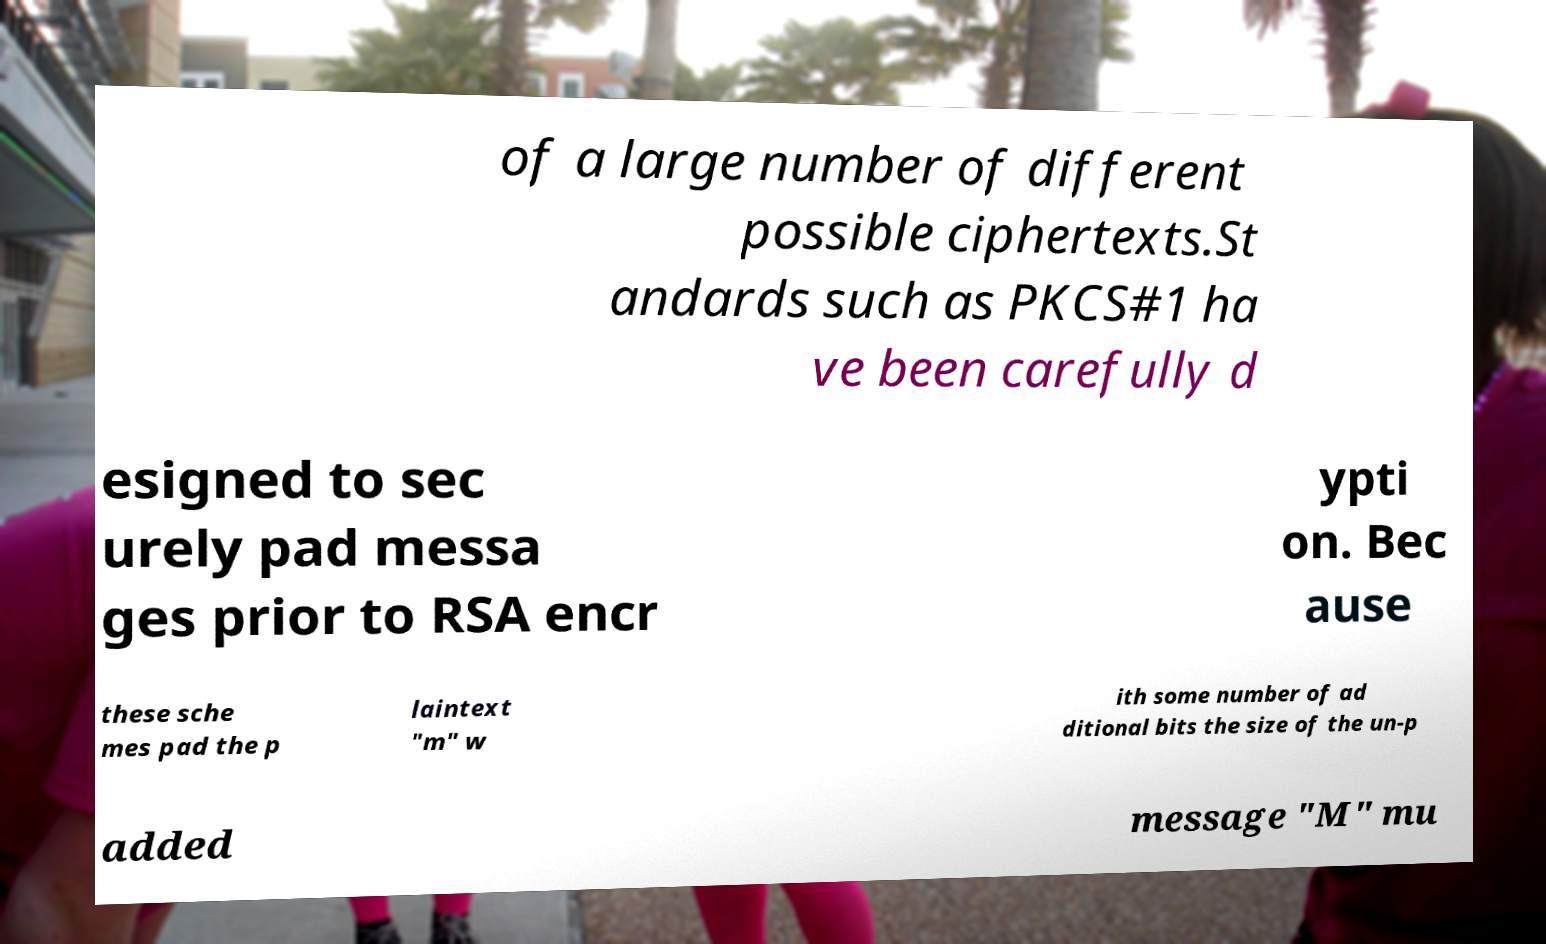There's text embedded in this image that I need extracted. Can you transcribe it verbatim? of a large number of different possible ciphertexts.St andards such as PKCS#1 ha ve been carefully d esigned to sec urely pad messa ges prior to RSA encr ypti on. Bec ause these sche mes pad the p laintext "m" w ith some number of ad ditional bits the size of the un-p added message "M" mu 